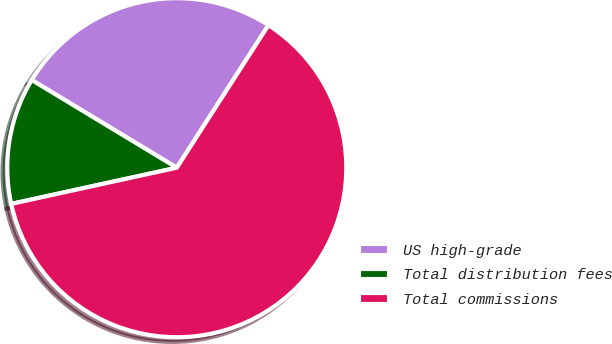Convert chart to OTSL. <chart><loc_0><loc_0><loc_500><loc_500><pie_chart><fcel>US high-grade<fcel>Total distribution fees<fcel>Total commissions<nl><fcel>25.44%<fcel>12.08%<fcel>62.48%<nl></chart> 